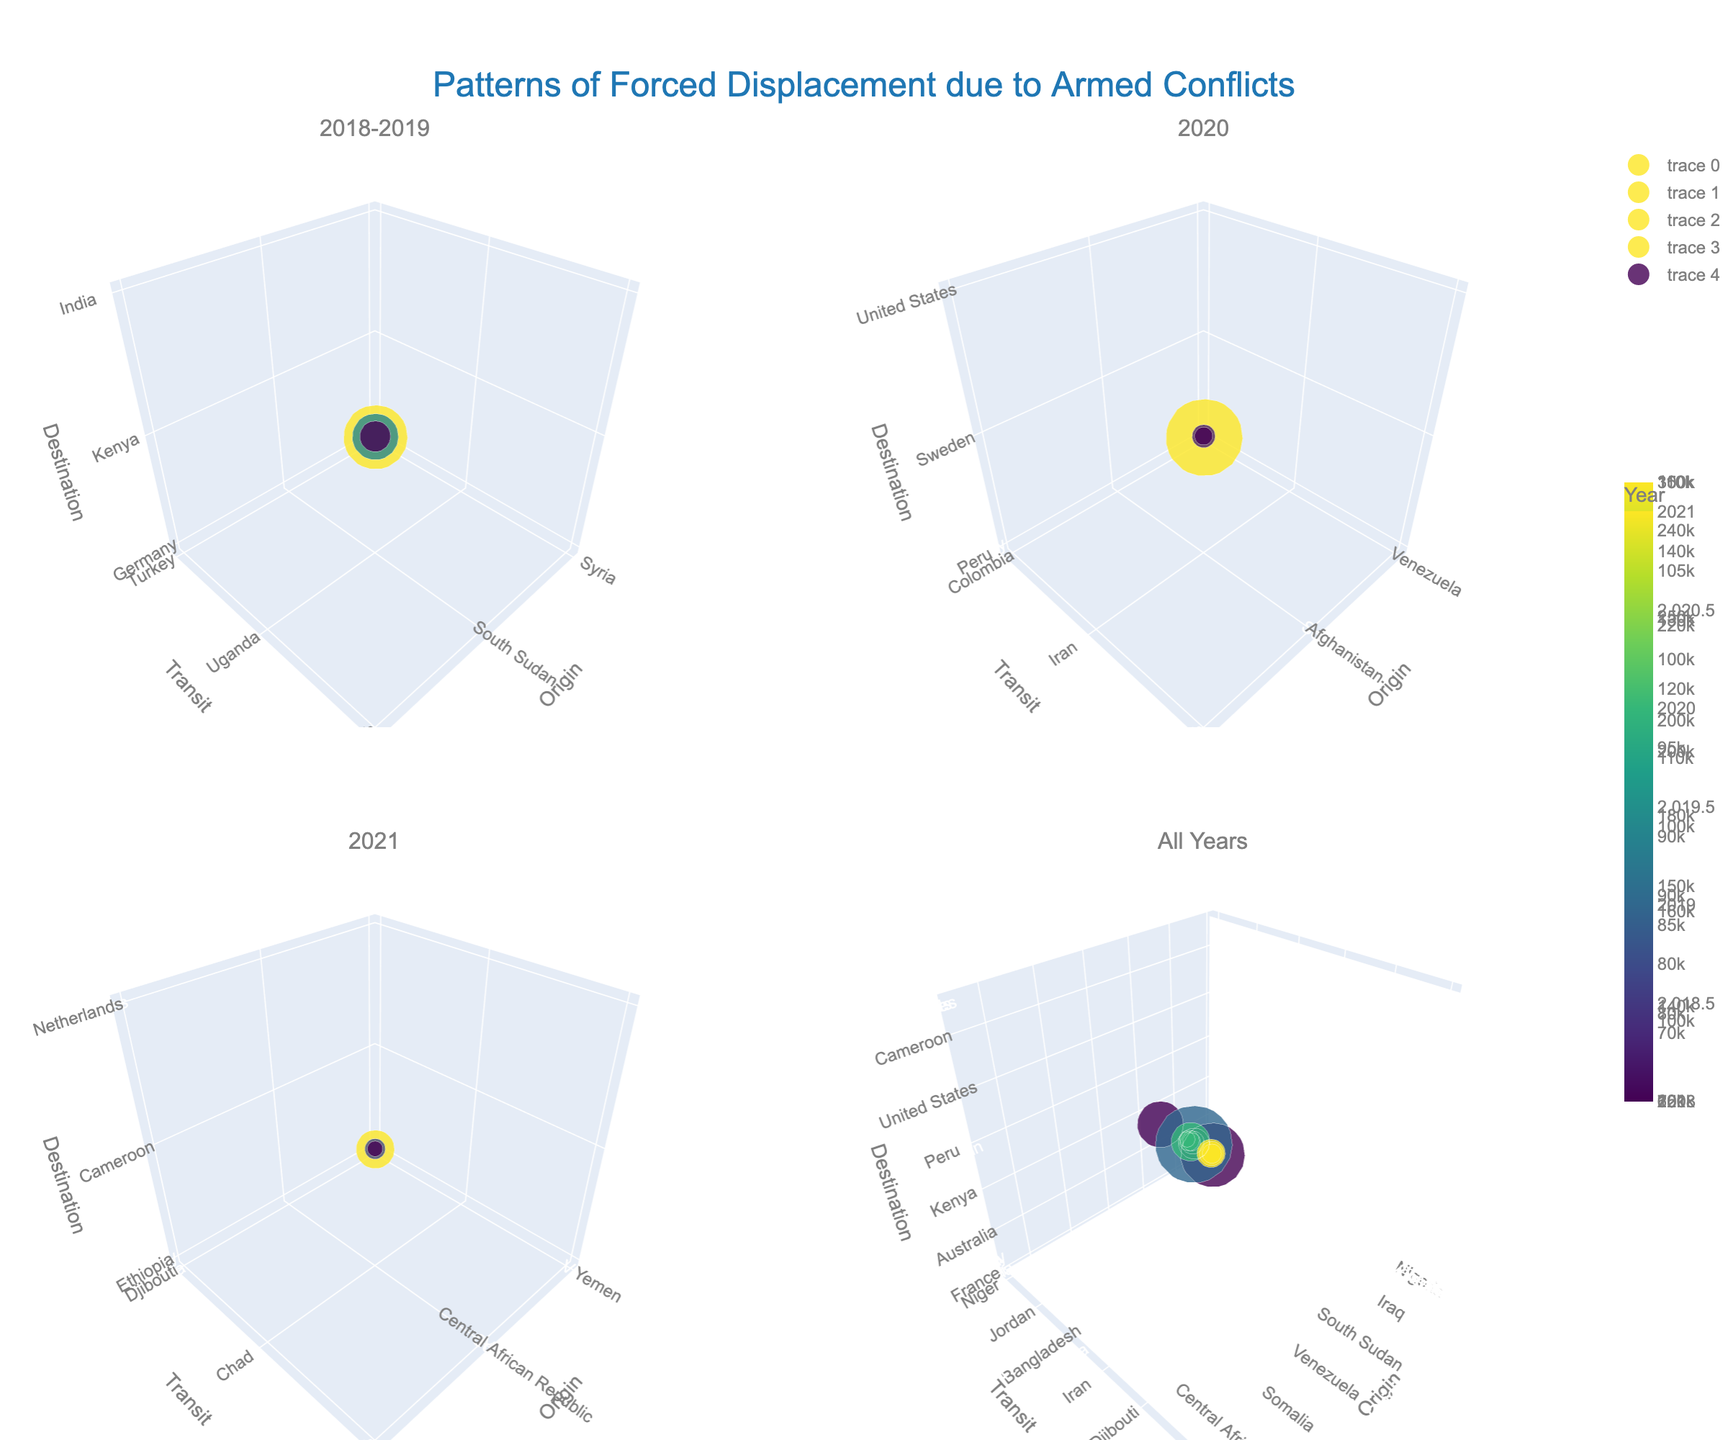What is the title of the figure? The title is usually displayed at the top of the figure. In this case, the title should be located at the center top and in a larger font size to make it stand out.
Answer: Patterns of Forced Displacement due to Armed Conflicts Which countries had the most displaced persons in 2019? Focus on the subplot labeled '2018-2019' and identify the markers representing 2019. The largest marker size in 2019 will correspond to Venezuela, Colombia, and Peru.
Answer: Venezuela, Colombia, and Peru How does the number of displaced persons from Nigeria in 2021 compare to that from South Sudan in 2018? Check the subplot labeled '2021' for Nigeria and the '2018-2019' subplot for South Sudan. Compare the size of the markers representing the displaced persons.
Answer: Nigeria (110,000) is higher than South Sudan (180,000) What pattern do you observe when comparing the displacement from the Middle East versus Africa? Look for markers representing Middle Eastern countries (e.g., Syria, Yemen) and African countries (e.g., South Sudan, Nigeria). Compare the sizes and distribution across the plots.
Answer: Middle Eastern displacements often end in Europe and have higher numbers; African displacements often end within Africa and have smaller numbers Which year had the highest total number of displaced persons? Sum the displaced persons for each year by adding the values of the markers. Identify the subplot where the summation is highest.
Answer: 2019 What is the role of 'Transit' countries in the plot, and how does it influence the overall pattern? Observe how transit countries are represented along the y-axis and note the connections between origin and destination through transit.
Answer: Transit countries act as intermediaries and often geographically bridge origin and destination locations Which destination country appears most frequently in the figure? Count the occurrences of each destination country across all subplots.
Answer: Kenya How does displacement from Afghanistan in 2019 compare to other origin countries that year? In the '2018-2019' subplot, compare the marker size for Afghanistan with other markers in 2019.
Answer: Afghanistan's displacement (90,000) is lower than Venezuela's but higher than Somalia's What can be inferred about the displacement trend between 2018 and 2021? Observe the size and distribution of markers across the different subplots from 2018 to 2021.
Answer: Displacement appears to peak in 2019 and then decreases slightly in later years Why might the 'All Years' subplot be useful in this figure? It consolidates data from all years, providing a comprehensive view of overall patterns and trends that might not be visible within individual years.
Answer: Provides a comprehensive view 